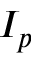<formula> <loc_0><loc_0><loc_500><loc_500>I _ { p }</formula> 